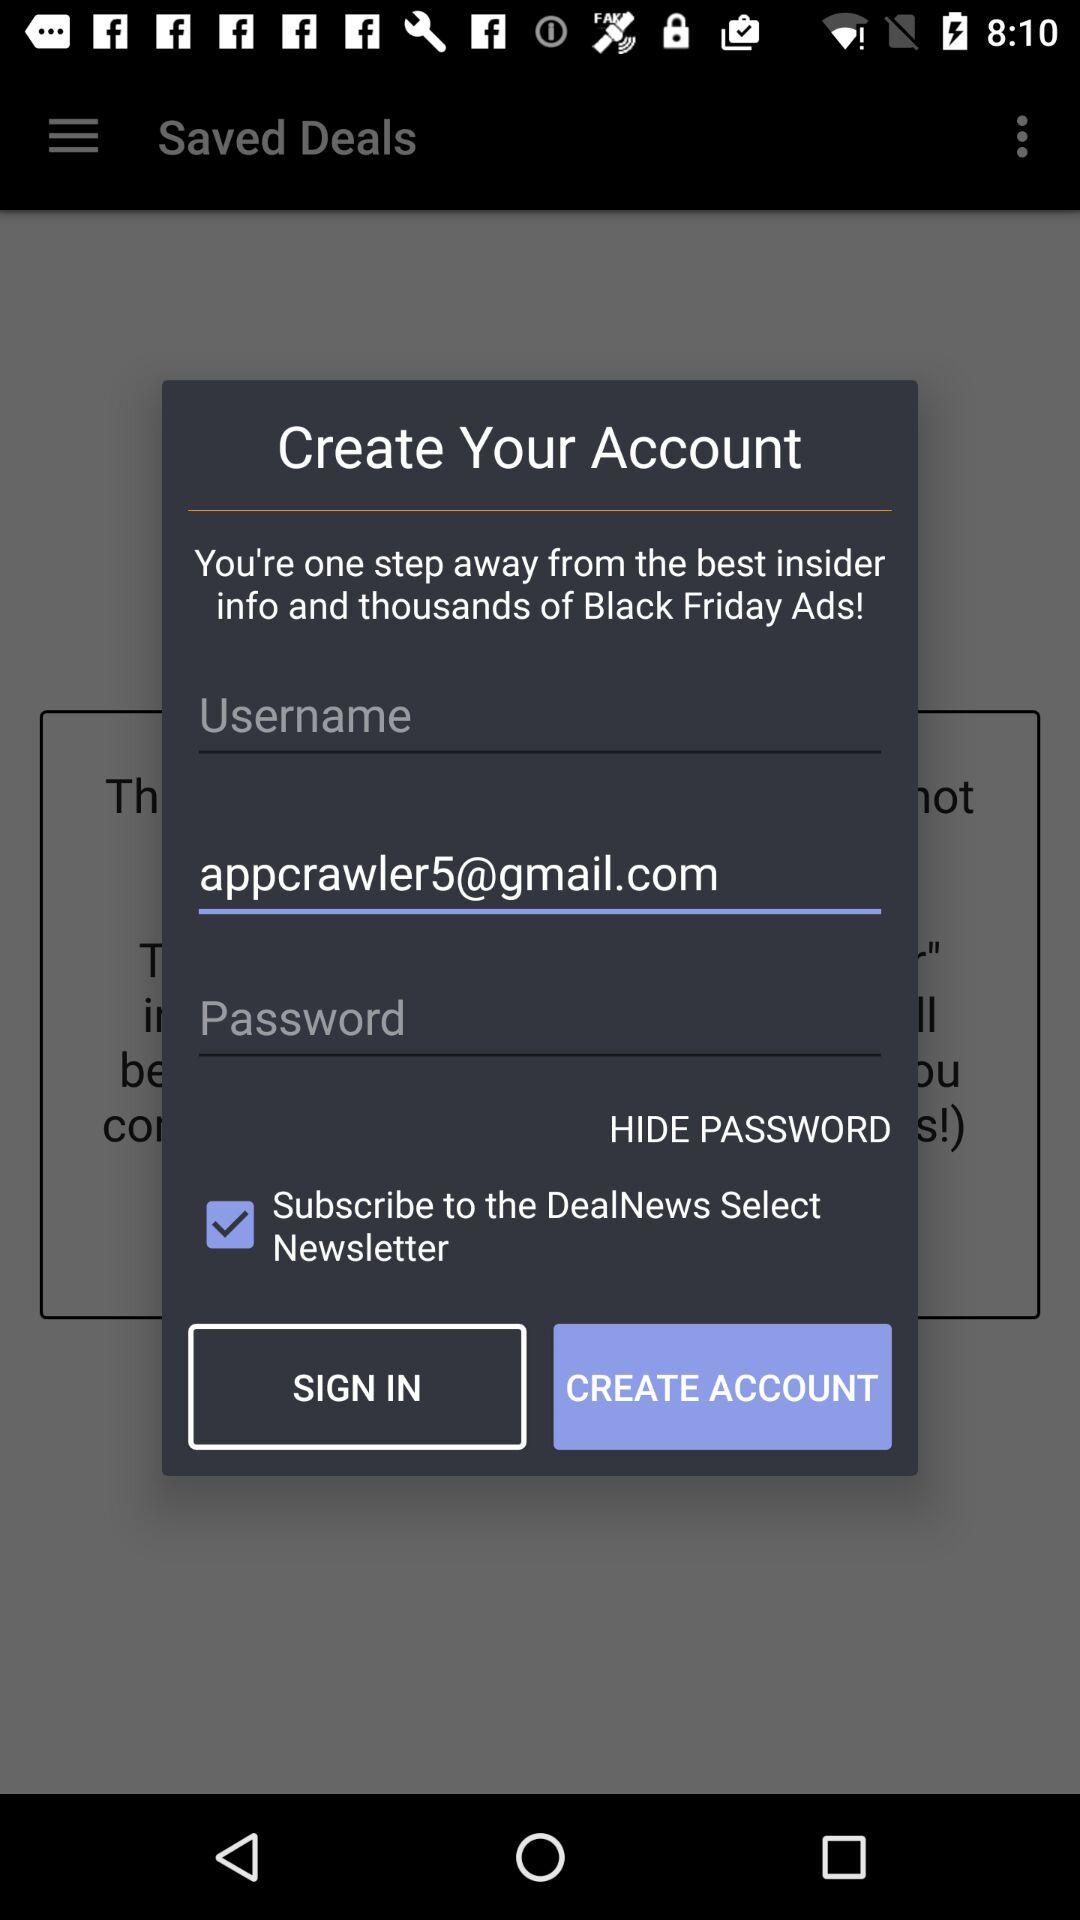What is the email address? The email address is appcrawler5@gmail.com. 